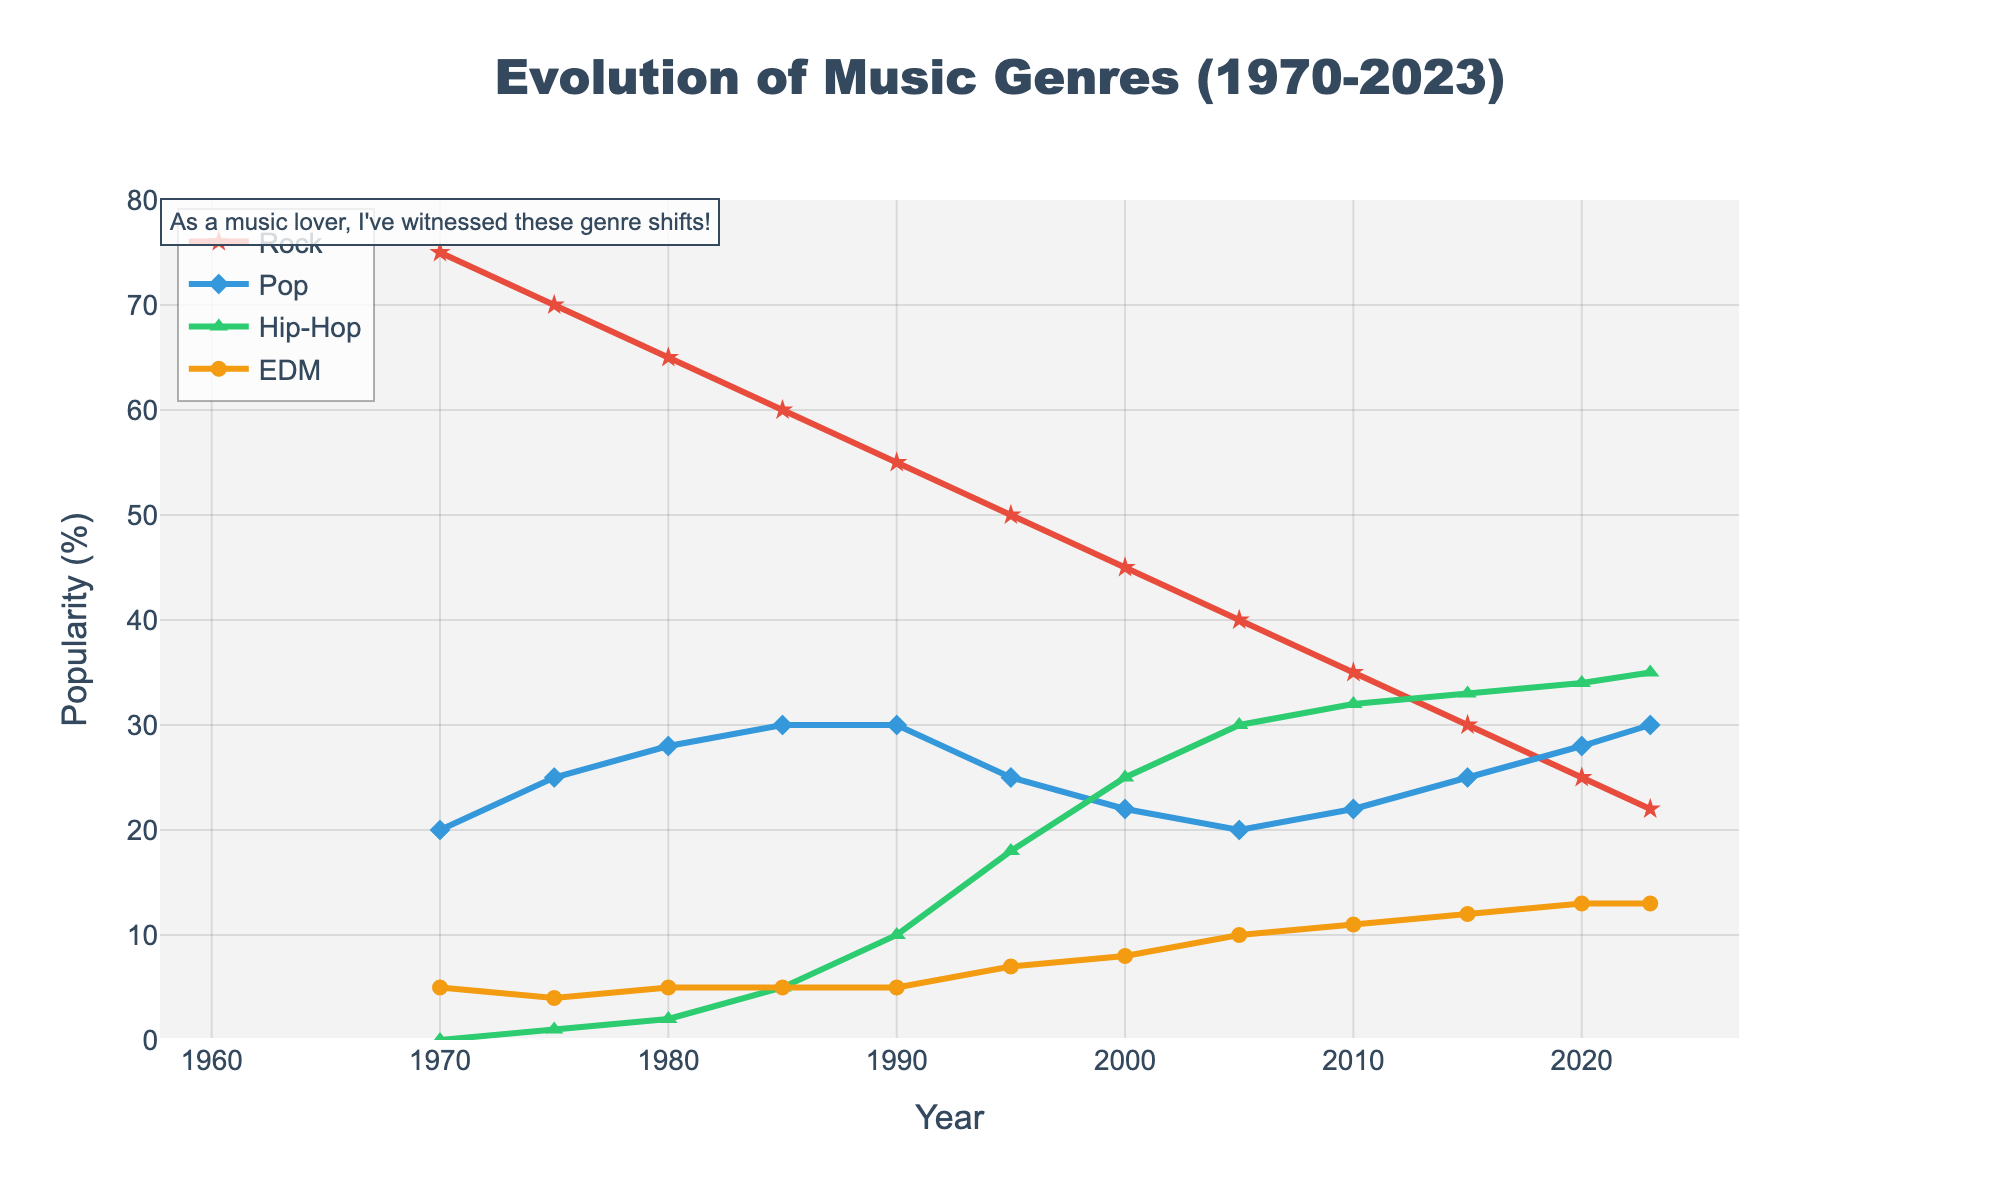Which music genre has the highest popularity in 1970? Observing the values on the y-axis for 1970, rock music has the highest popularity at 75%.
Answer: Rock By how many percentage points did the popularity of rock music decrease from 1970 to 2023? Subtract the popularity of rock music in 2023 (22) from the value in 1970 (75): 75 - 22 = 53.
Answer: 53 Which genre surpasses rock in popularity around 2005? In 2005, hip-hop becomes more popular than rock, with hip-hop at 30% and rock at 40%. By 2010, hip-hop is more popular than rock.
Answer: Hip-Hop Compare the popularity trends of EDM and pop music from 1980 to 2023. Which genre shows a more significant increase? EDM increases from 5% in 1980 to 13% in 2023. Pop increases from 28% in 1980 to 30% in 2023. Increase for EDM is 13 - 5 = 8, while for pop it is 30 - 28 = 2. Thus, EDM shows a more significant increase.
Answer: Electronic Dance Music (EDM) What trend can be observed in the popularity of hip-hop music from 1985 to 2023? The popularity of hip-hop consistently rises from 5% in 1985, reaching 35% in 2023.
Answer: Rising trend What is the combined popularity of rock and hip-hop in 2015? Add the popularity percentages of rock (30) and hip-hop (33) in 2015: 30 + 33 = 63.
Answer: 63 Which genre appears to have the most stable popularity trend from 1970 to 2023? Pop music remains relatively stable, fluctuating between 20% to 30%, showing less dramatic changes compared to other genres.
Answer: Pop In which year did rock and pop music have equal popularity? In 1995, rock and pop both have a popularity of 25%.
Answer: 1995 Between 1970 and 2023, which genre first surpassed 30% in popularity and in which year? Rock remained above 30% from the beginning, while hip-hop surpassed 30% in 2005.
Answer: Rock in 1970; Hip-Hop in 2005 